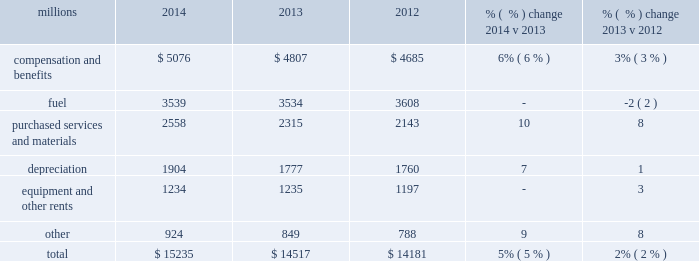Operating expenses millions 2014 2013 2012 % (  % ) change 2014 v 2013 % (  % ) change 2013 v 2012 .
Operating expenses increased $ 718 million in 2014 versus 2013 .
Volume-related expenses , incremental costs associated with operating a slower network , depreciation , wage and benefit inflation , and locomotive and freight car materials contributed to the higher costs .
Lower fuel price partially offset these increases .
In addition , there were approximately $ 35 million of weather related costs in the first quarter of operating expenses increased $ 336 million in 2013 versus 2012 .
Wage and benefit inflation , new logistics management fees and container costs for our automotive business , locomotive overhauls , property taxes and repairs on jointly owned property contributed to higher expenses during the year .
Lower fuel prices partially offset the cost increases .
Compensation and benefits 2013 compensation and benefits include wages , payroll taxes , health and welfare costs , pension costs , other postretirement benefits , and incentive costs .
Volume-related expenses , including training , and a slower network increased our train and engine work force , which , along with general wage and benefit inflation , drove increased wages .
Weather-related costs in the first quarter of 2014 also increased costs .
General wages and benefits inflation , including increased pension and other postretirement benefits , and higher work force levels drove the increases in 2013 versus 2012 .
The impact of ongoing productivity initiatives partially offset these increases .
Fuel 2013 fuel includes locomotive fuel and gasoline for highway and non-highway vehicles and heavy equipment .
Volume growth of 7% ( 7 % ) , as measured by gross ton-miles , drove the increase in fuel expense .
This was essentially offset by lower locomotive diesel fuel prices , which averaged $ 2.97 per gallon ( including taxes and transportation costs ) in 2014 , compared to $ 3.15 in 2013 , along with a slight improvement in fuel consumption rate , computed as gallons of fuel consumed divided by gross ton-miles .
Lower locomotive diesel fuel prices , which averaged $ 3.15 per gallon ( including taxes and transportation costs ) in 2013 , compared to $ 3.22 in 2012 , decreased expenses by $ 75 million .
Volume , as measured by gross ton-miles , decreased 1% ( 1 % ) while the fuel consumption rate , computed as gallons of fuel consumed divided by gross ton-miles , increased 2% ( 2 % ) compared to 2012 .
Declines in heavier , more fuel-efficient coal shipments drove the variances in gross-ton-miles and the fuel consumption rate .
Purchased services and materials 2013 expense for purchased services and materials includes the costs of services purchased from outside contractors and other service providers ( including equipment maintenance and contract expenses incurred by our subsidiaries for external transportation services ) ; materials used to maintain the railroad 2019s lines , structures , and equipment ; costs of operating facilities jointly used by uprr and other railroads ; transportation and lodging for train crew employees ; trucking and contracting costs for intermodal containers ; leased automobile maintenance expenses ; and tools and supplies .
Expenses for purchased services increased 8% ( 8 % ) compared to 2013 primarily due to volume- 2014 operating expenses .
What would total 2015 operating expenses be if they grow at the same rate as 2014 volume growth , in millions? 
Computations: (15235 + 7%)
Answer: 15235.07. Operating expenses millions 2014 2013 2012 % (  % ) change 2014 v 2013 % (  % ) change 2013 v 2012 .
Operating expenses increased $ 718 million in 2014 versus 2013 .
Volume-related expenses , incremental costs associated with operating a slower network , depreciation , wage and benefit inflation , and locomotive and freight car materials contributed to the higher costs .
Lower fuel price partially offset these increases .
In addition , there were approximately $ 35 million of weather related costs in the first quarter of operating expenses increased $ 336 million in 2013 versus 2012 .
Wage and benefit inflation , new logistics management fees and container costs for our automotive business , locomotive overhauls , property taxes and repairs on jointly owned property contributed to higher expenses during the year .
Lower fuel prices partially offset the cost increases .
Compensation and benefits 2013 compensation and benefits include wages , payroll taxes , health and welfare costs , pension costs , other postretirement benefits , and incentive costs .
Volume-related expenses , including training , and a slower network increased our train and engine work force , which , along with general wage and benefit inflation , drove increased wages .
Weather-related costs in the first quarter of 2014 also increased costs .
General wages and benefits inflation , including increased pension and other postretirement benefits , and higher work force levels drove the increases in 2013 versus 2012 .
The impact of ongoing productivity initiatives partially offset these increases .
Fuel 2013 fuel includes locomotive fuel and gasoline for highway and non-highway vehicles and heavy equipment .
Volume growth of 7% ( 7 % ) , as measured by gross ton-miles , drove the increase in fuel expense .
This was essentially offset by lower locomotive diesel fuel prices , which averaged $ 2.97 per gallon ( including taxes and transportation costs ) in 2014 , compared to $ 3.15 in 2013 , along with a slight improvement in fuel consumption rate , computed as gallons of fuel consumed divided by gross ton-miles .
Lower locomotive diesel fuel prices , which averaged $ 3.15 per gallon ( including taxes and transportation costs ) in 2013 , compared to $ 3.22 in 2012 , decreased expenses by $ 75 million .
Volume , as measured by gross ton-miles , decreased 1% ( 1 % ) while the fuel consumption rate , computed as gallons of fuel consumed divided by gross ton-miles , increased 2% ( 2 % ) compared to 2012 .
Declines in heavier , more fuel-efficient coal shipments drove the variances in gross-ton-miles and the fuel consumption rate .
Purchased services and materials 2013 expense for purchased services and materials includes the costs of services purchased from outside contractors and other service providers ( including equipment maintenance and contract expenses incurred by our subsidiaries for external transportation services ) ; materials used to maintain the railroad 2019s lines , structures , and equipment ; costs of operating facilities jointly used by uprr and other railroads ; transportation and lodging for train crew employees ; trucking and contracting costs for intermodal containers ; leased automobile maintenance expenses ; and tools and supplies .
Expenses for purchased services increased 8% ( 8 % ) compared to 2013 primarily due to volume- 2014 operating expenses .
What percentage of total operating expenses was fuel in 2014? 
Computations: (3539 / 15235)
Answer: 0.23229. Operating expenses millions 2014 2013 2012 % (  % ) change 2014 v 2013 % (  % ) change 2013 v 2012 .
Operating expenses increased $ 718 million in 2014 versus 2013 .
Volume-related expenses , incremental costs associated with operating a slower network , depreciation , wage and benefit inflation , and locomotive and freight car materials contributed to the higher costs .
Lower fuel price partially offset these increases .
In addition , there were approximately $ 35 million of weather related costs in the first quarter of operating expenses increased $ 336 million in 2013 versus 2012 .
Wage and benefit inflation , new logistics management fees and container costs for our automotive business , locomotive overhauls , property taxes and repairs on jointly owned property contributed to higher expenses during the year .
Lower fuel prices partially offset the cost increases .
Compensation and benefits 2013 compensation and benefits include wages , payroll taxes , health and welfare costs , pension costs , other postretirement benefits , and incentive costs .
Volume-related expenses , including training , and a slower network increased our train and engine work force , which , along with general wage and benefit inflation , drove increased wages .
Weather-related costs in the first quarter of 2014 also increased costs .
General wages and benefits inflation , including increased pension and other postretirement benefits , and higher work force levels drove the increases in 2013 versus 2012 .
The impact of ongoing productivity initiatives partially offset these increases .
Fuel 2013 fuel includes locomotive fuel and gasoline for highway and non-highway vehicles and heavy equipment .
Volume growth of 7% ( 7 % ) , as measured by gross ton-miles , drove the increase in fuel expense .
This was essentially offset by lower locomotive diesel fuel prices , which averaged $ 2.97 per gallon ( including taxes and transportation costs ) in 2014 , compared to $ 3.15 in 2013 , along with a slight improvement in fuel consumption rate , computed as gallons of fuel consumed divided by gross ton-miles .
Lower locomotive diesel fuel prices , which averaged $ 3.15 per gallon ( including taxes and transportation costs ) in 2013 , compared to $ 3.22 in 2012 , decreased expenses by $ 75 million .
Volume , as measured by gross ton-miles , decreased 1% ( 1 % ) while the fuel consumption rate , computed as gallons of fuel consumed divided by gross ton-miles , increased 2% ( 2 % ) compared to 2012 .
Declines in heavier , more fuel-efficient coal shipments drove the variances in gross-ton-miles and the fuel consumption rate .
Purchased services and materials 2013 expense for purchased services and materials includes the costs of services purchased from outside contractors and other service providers ( including equipment maintenance and contract expenses incurred by our subsidiaries for external transportation services ) ; materials used to maintain the railroad 2019s lines , structures , and equipment ; costs of operating facilities jointly used by uprr and other railroads ; transportation and lodging for train crew employees ; trucking and contracting costs for intermodal containers ; leased automobile maintenance expenses ; and tools and supplies .
Expenses for purchased services increased 8% ( 8 % ) compared to 2013 primarily due to volume- 2014 operating expenses .
What percentage of total operating expenses was fuel in 2013? 
Computations: (3534 / 14517)
Answer: 0.24344. 